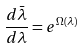Convert formula to latex. <formula><loc_0><loc_0><loc_500><loc_500>\frac { d \bar { \lambda } } { d \lambda } = e ^ { \Omega ( \lambda ) }</formula> 